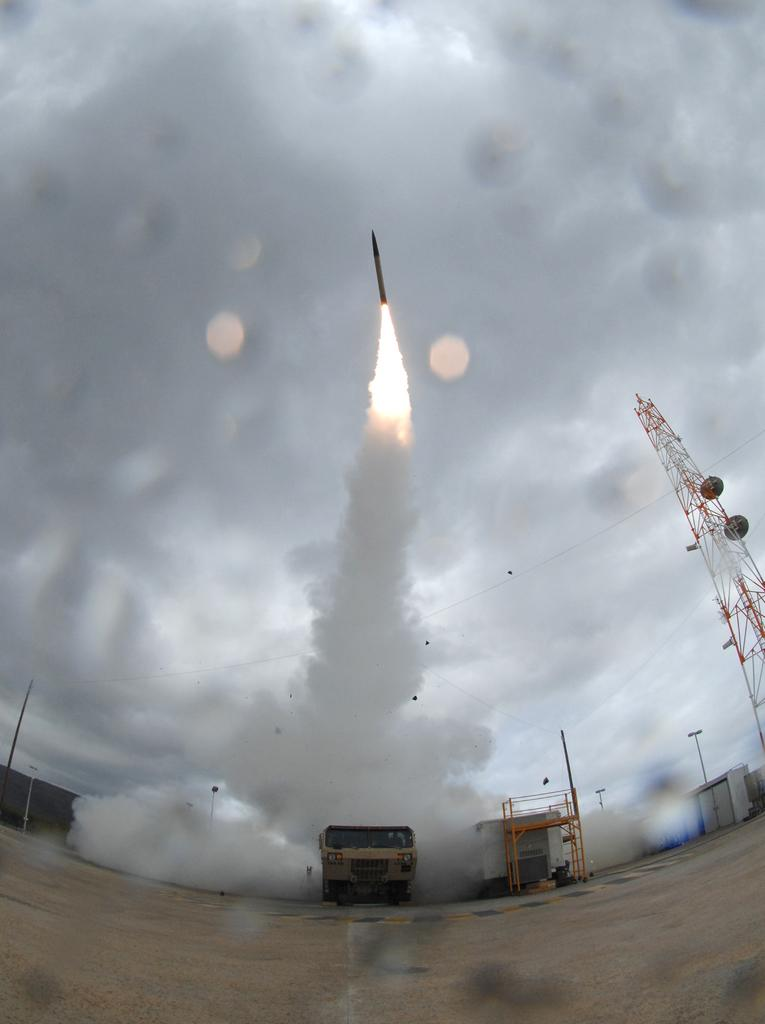What is the main subject in the image? There is a vehicle in the image. What type of structure can be seen in the image? There is a metal structure in the image. What are the poles used for in the image? The poles are likely used for supporting the metal structure or other elements in the image. What type of establishment might be present in the image? It appears to be stores in the image. What type of building is present in the image? There is a shed in the image. What can be seen in the foreground area of the image? There is smoke in the foreground area of the image. What is happening in the background of the image? There is a rocket and fire in the background of the image. What part of the natural environment is visible in the image? The sky is visible in the background of the image. What type of need can be seen growing in the image? There is no reference to a need in the image; it features a vehicle, metal structure, poles, stores, shed, smoke, rocket, fire, and sky. What action is the rocket performing in the image? The rocket is not performing any action in the image; it is simply present in the background. 